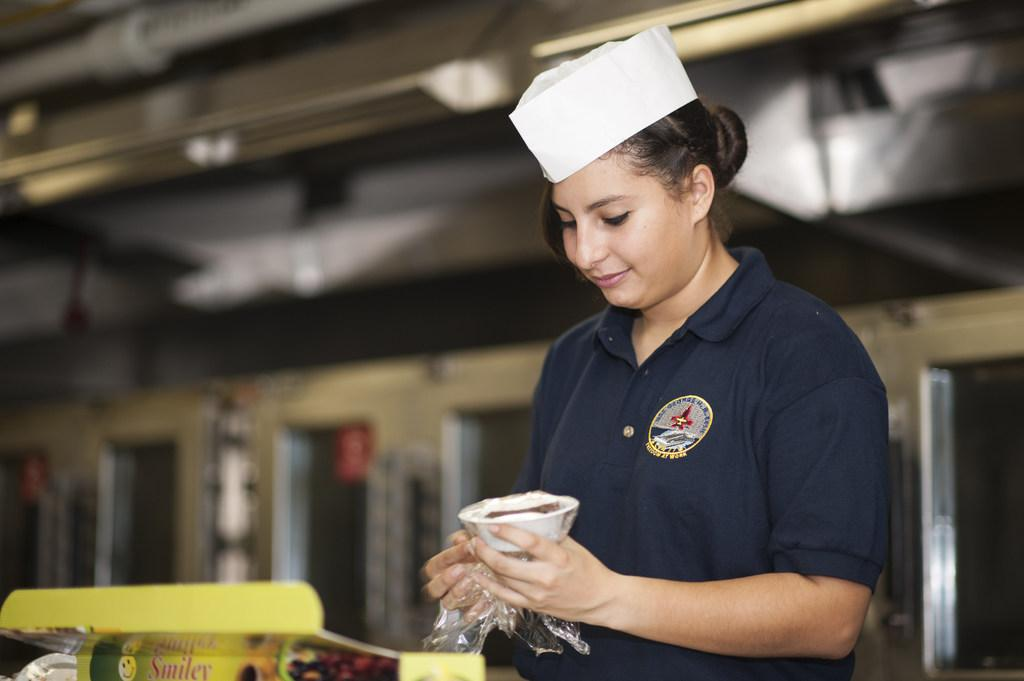What is the main subject in the image? There is a person in the image. What is the person holding in the image? The person is holding a cup. What can be seen in front of the person? There are objects in front of the person. What is visible behind the person? There are doors visible behind the person. What is located at the top of the image? There are lights at the top of the image. What type of pail is being used to create the fog in the image? There is no pail or fog present in the image. 